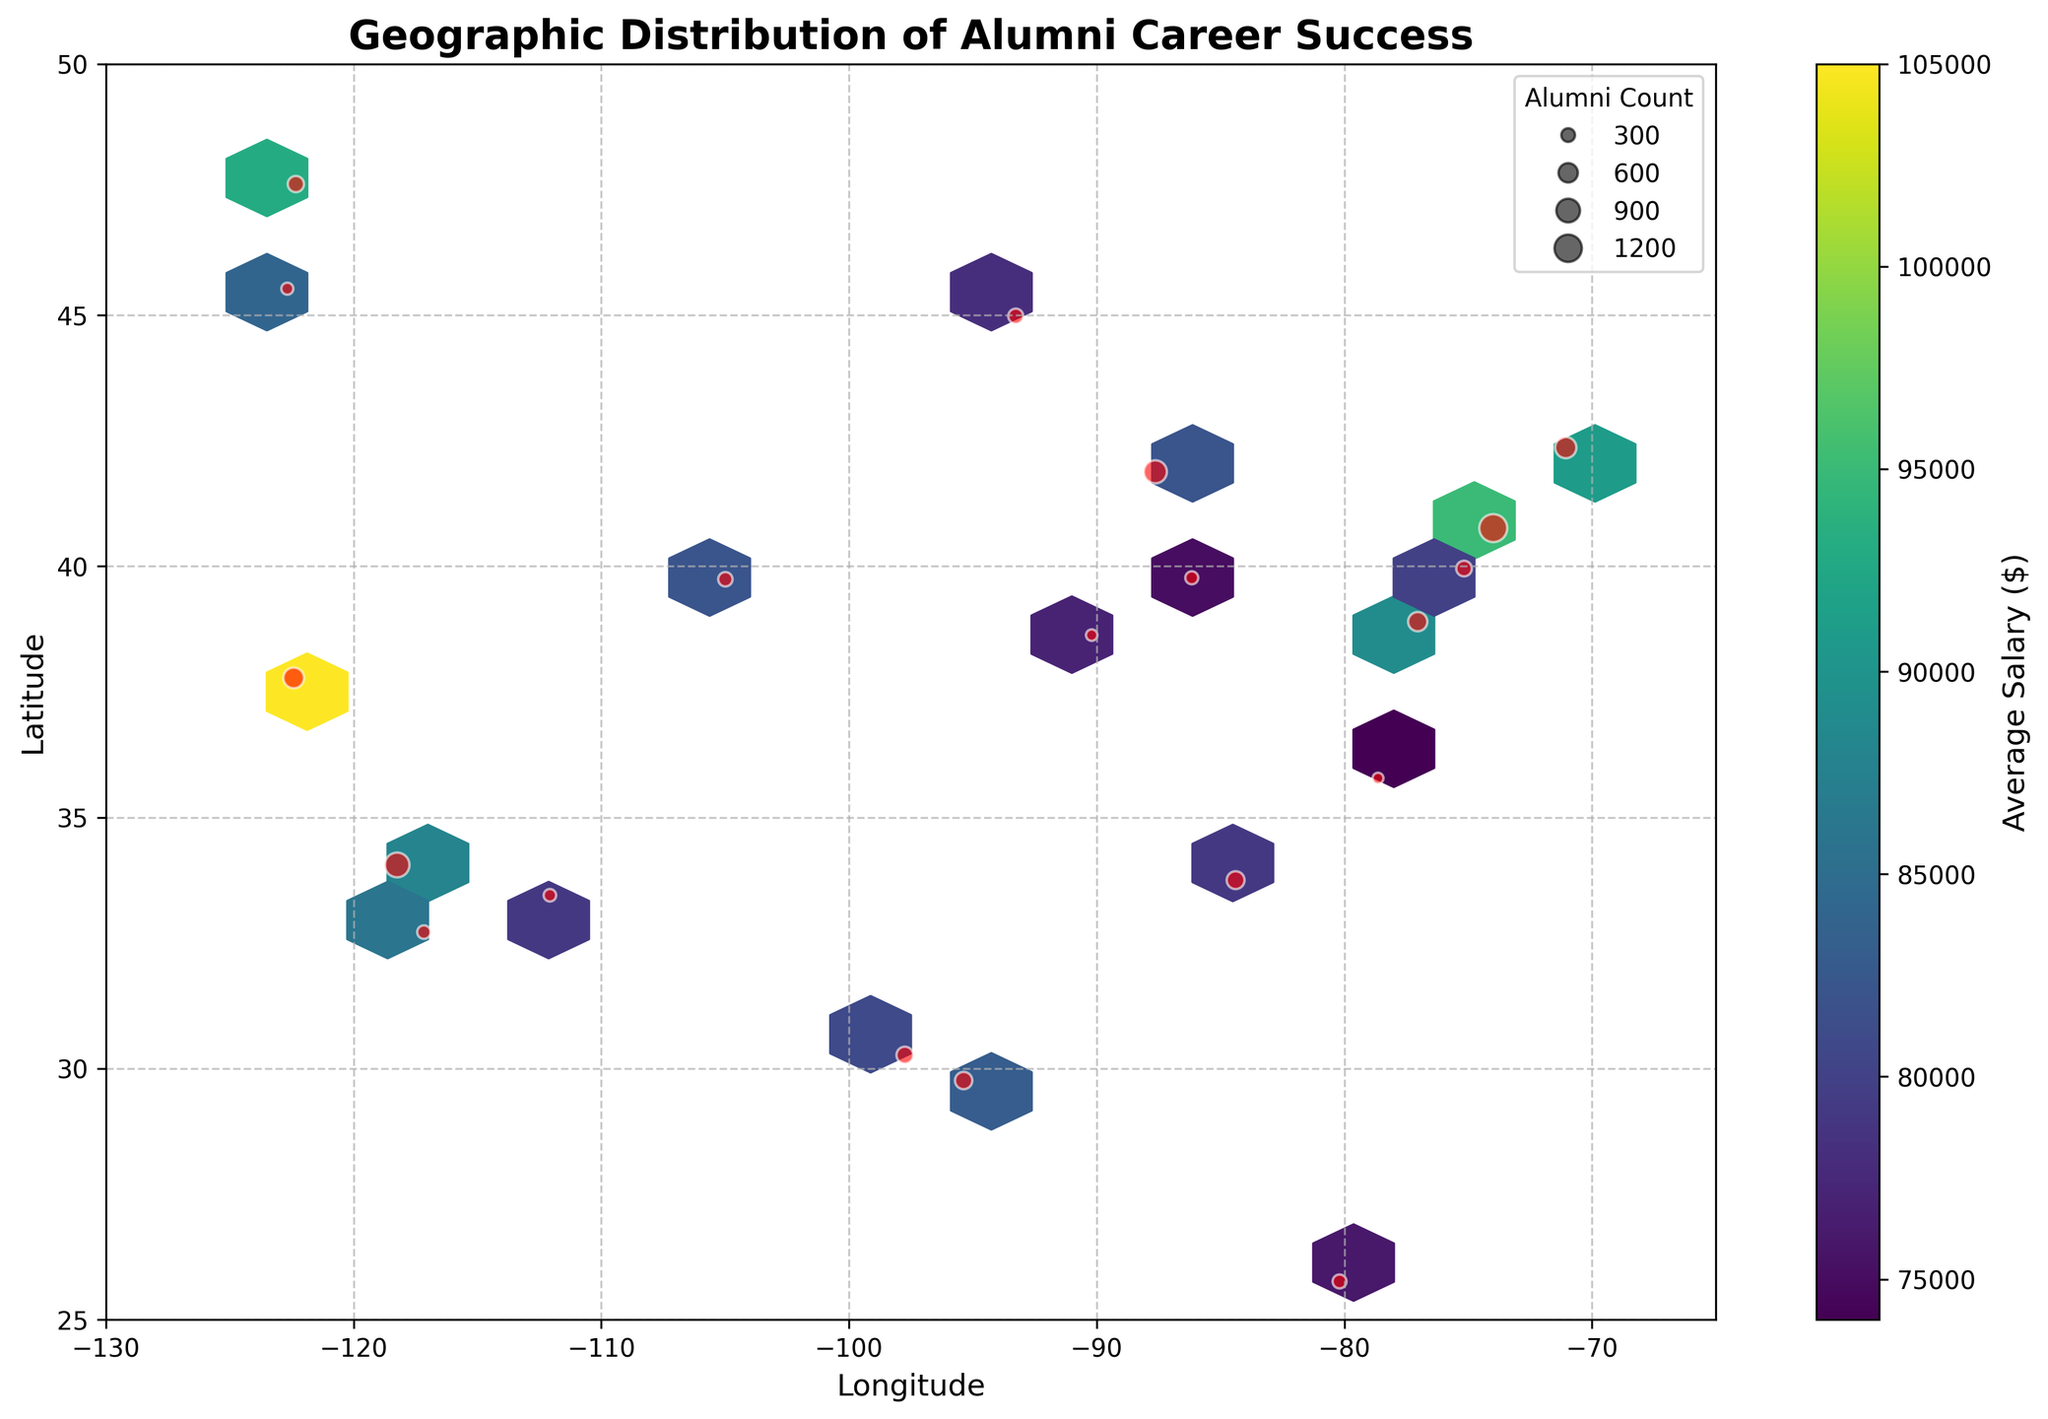What is the title of the figure? The title of a figure usually appears at the top and provides a summary of what the plot represents. In this case, the title is clearly mentioned at the top center of the plot.
Answer: Geographic Distribution of Alumni Career Success What does the color represent in the hexbin plot? The color in a hexbin plot often represents the density of a third variable. In this plot, the color bar on the right indicates that the color represents average salary.
Answer: Average Salary Which city has the highest alumni count? To find the city with the highest alumni count, look for the biggest red scatter point on the plot. According to the scatter plot, the largest red dot is located at the coordinates corresponding to New York City.
Answer: New York City Which area shows the highest average salary according to the color scale? To find the area with the highest average salary, look for the darkest color on the hexbin plot, as indicated by the color scale on the right. The darkest hexagon, which is the brightest in the viridis color map, is around San Francisco.
Answer: San Francisco Which cities have an average salary of above $100,000? For this, reference the hexagons that have colors corresponding to an average salary of above $100,000 on the color scale. The plot shows that hexagons around San Francisco have an average salary of above $100,000.
Answer: San Francisco How does the alumni count in Los Angeles compare to Chicago? Compare the sizes of the scatter points located at the coordinates for Los Angeles and Chicago. The scatter point in Los Angeles (slightly larger red dot) is larger than the one in Chicago, indicating a higher alumni count in Los Angeles.
Answer: Los Angeles > Chicago What can be inferred about the employment location with an average salary of $90,000 - $100,000? To infer the employment locations within this salary range, identify the hexagons colored between the $90,000 and $100,000 range according to the color scale. These spots include locations around New York City and Seattle.
Answer: New York City, Seattle Which coordinate points to Boston on the plot? To determine the coordinate points corresponding to Boston, look for the distinct scatter point also matching the latitude and longitude values for Boston. The coordinates are approximately -71.058, 42.36.
Answer: (-71.058, 42.36) Which region in the US has the densest concentration of alumni? This question requires identifying the most densely populated area based on the scatter's density and the hexbin plot's concentration. The northeast, particularly around New York City, shows the densest concentration of alumni.
Answer: Northeast (around New York City) How does the average salary in Miami compare to Houston? Compare the color of the hexagons for Miami and Houston, referring to the color scale for average salary. The colors suggest that Houston's average salary appears slightly higher than Miami's.
Answer: Houston > Miami 